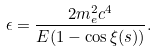Convert formula to latex. <formula><loc_0><loc_0><loc_500><loc_500>\epsilon = \frac { 2 m _ { e } ^ { 2 } c ^ { 4 } } { E ( 1 - \cos \xi ( s ) ) } .</formula> 